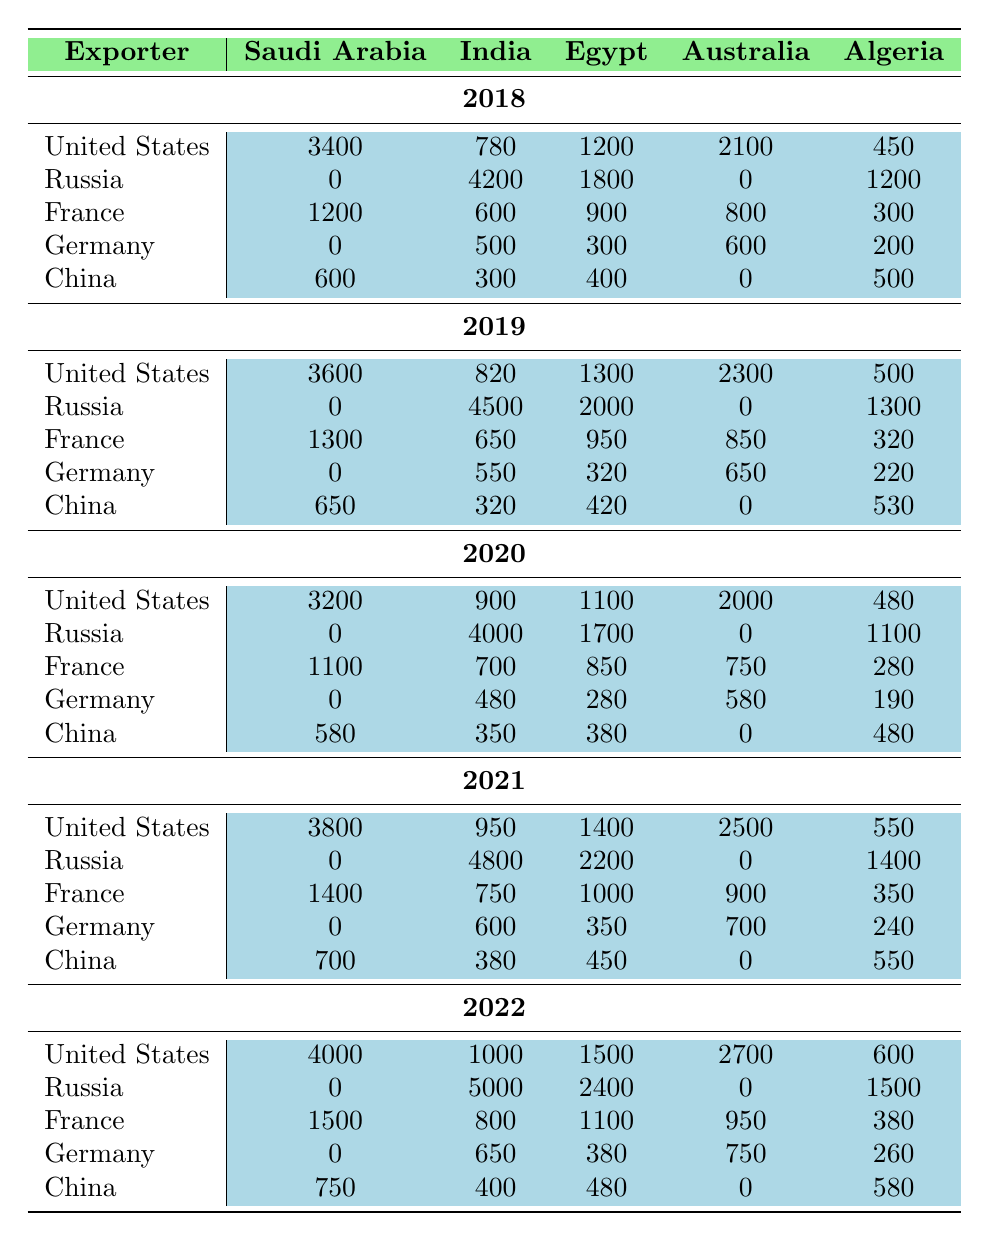What was the total value of arms imported by Saudi Arabia from the United States in 2022? From the table, we can see that in 2022, Saudi Arabia imported arms worth 4000 from the United States.
Answer: 4000 Which country imported the most arms from Russia in 2022? Referring to the table for the year 2022, India imported the most arms from Russia, totaling 5000.
Answer: India What was the average annual arms import by Australia from the United States over the years 2018 to 2022? To find the average, we sum the values for Australia from the United States across the five years: 2100 + 2300 + 2000 + 2500 + 2700 = 11600, then divide by 5 to get 11600/5 = 2320.
Answer: 2320 Did Germany export any arms to Saudi Arabia from 2018 to 2022? Looking at the table, we see that Germany has a value of 0 for arms exports to Saudi Arabia every year from 2018 to 2022. Hence, the statement is true.
Answer: No What is the trend of arms exports from the United States to Egypt from 2018 to 2022? We observe the values for Egypt from the United States over the years: 1200, 1300, 1100, 1400, 1500. The trend goes up and down initially, but overall it shows an increasing pattern by 2022.
Answer: Increasing In which year did France export the highest amount of arms to Saudi Arabia? From the table for France, the highest arms export to Saudi Arabia was in 2021, which totaled 1400.
Answer: 2021 What was the difference in total arms exports from China to Algeria between 2018 and 2022? Looking at the values for China to Algeria: in 2018 it was 500, and in 2022 it was 580. The difference is 580 - 500 = 80.
Answer: 80 Which exporting country had the highest total arms exports to India from 2018 to 2022? We need to sum the values for India across all exporters from the table: United States (780 + 820 + 900 + 950 + 1000 = 3450), Russia (4200 + 4500 + 4000 + 4800 + 5000 = 22500), France (600 + 650 + 700 + 750 + 800 = 3500), Germany (500 + 550 + 480 + 600 + 650 = 2880), China (300 + 320 + 350 + 380 + 400 = 1750). The highest total is from Russia with 22500.
Answer: Russia What was the total arms import value for Egypt from 2019 to 2022? Summing the values for Egypt from each of the years 2019 to 2022: 2000 (2019) + 1700 (2020) + 2200 (2021) + 2400 (2022) = 8300.
Answer: 8300 Over the five-year period, how did the arms exports from the United States to Saudi Arabia change? The values for the United States to Saudi Arabia are 3400, 3600, 3200, 3800, and 4000. They generally show an upward trend with a small dip in 2020.
Answer: Upward trend with a dip in 2020 